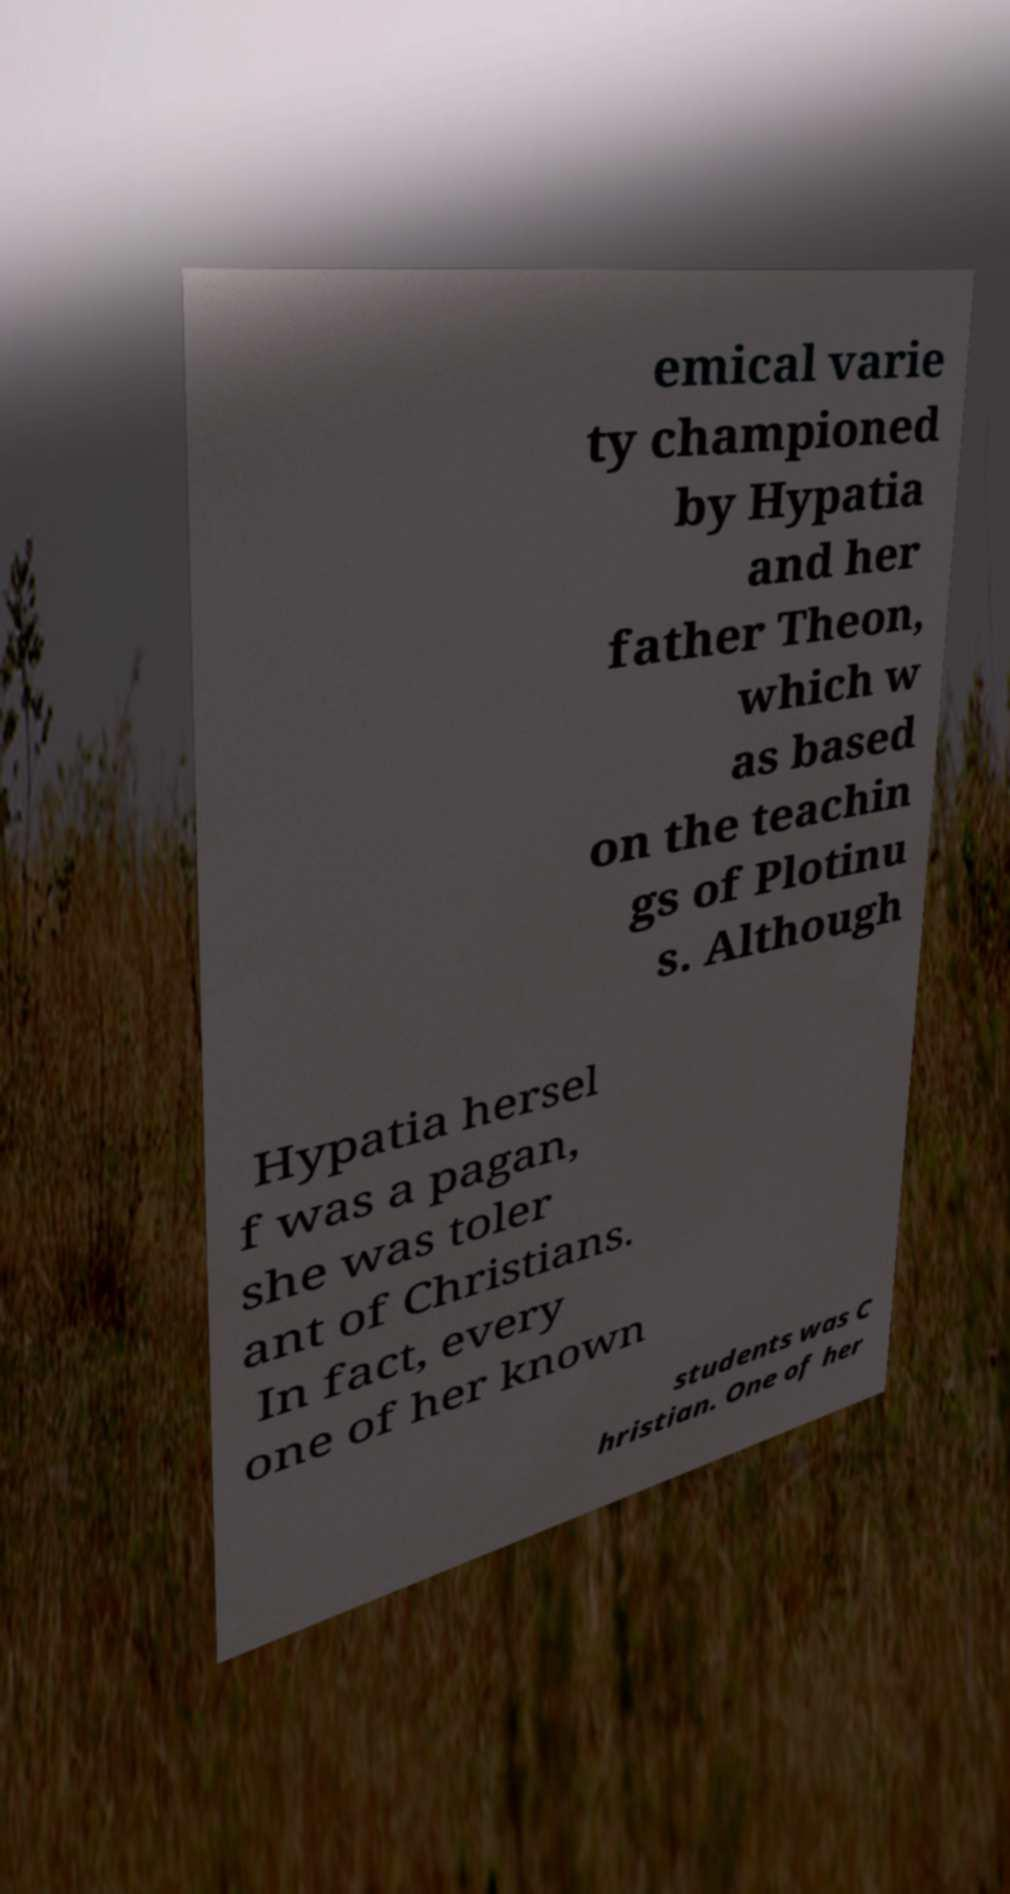Can you read and provide the text displayed in the image?This photo seems to have some interesting text. Can you extract and type it out for me? emical varie ty championed by Hypatia and her father Theon, which w as based on the teachin gs of Plotinu s. Although Hypatia hersel f was a pagan, she was toler ant of Christians. In fact, every one of her known students was C hristian. One of her 